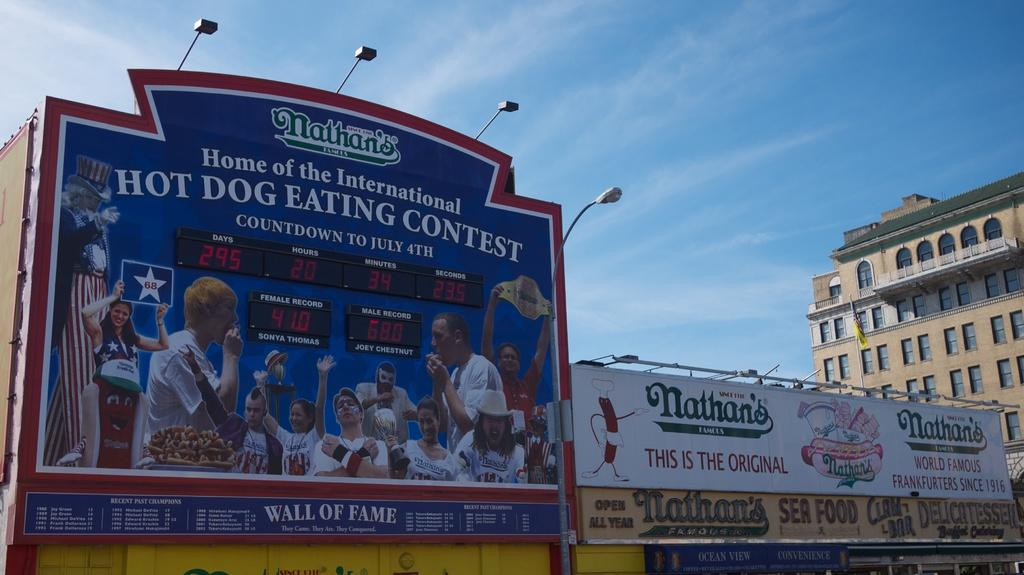<image>
Render a clear and concise summary of the photo. The sign is advertising the Nathan's hot dog eating contest 